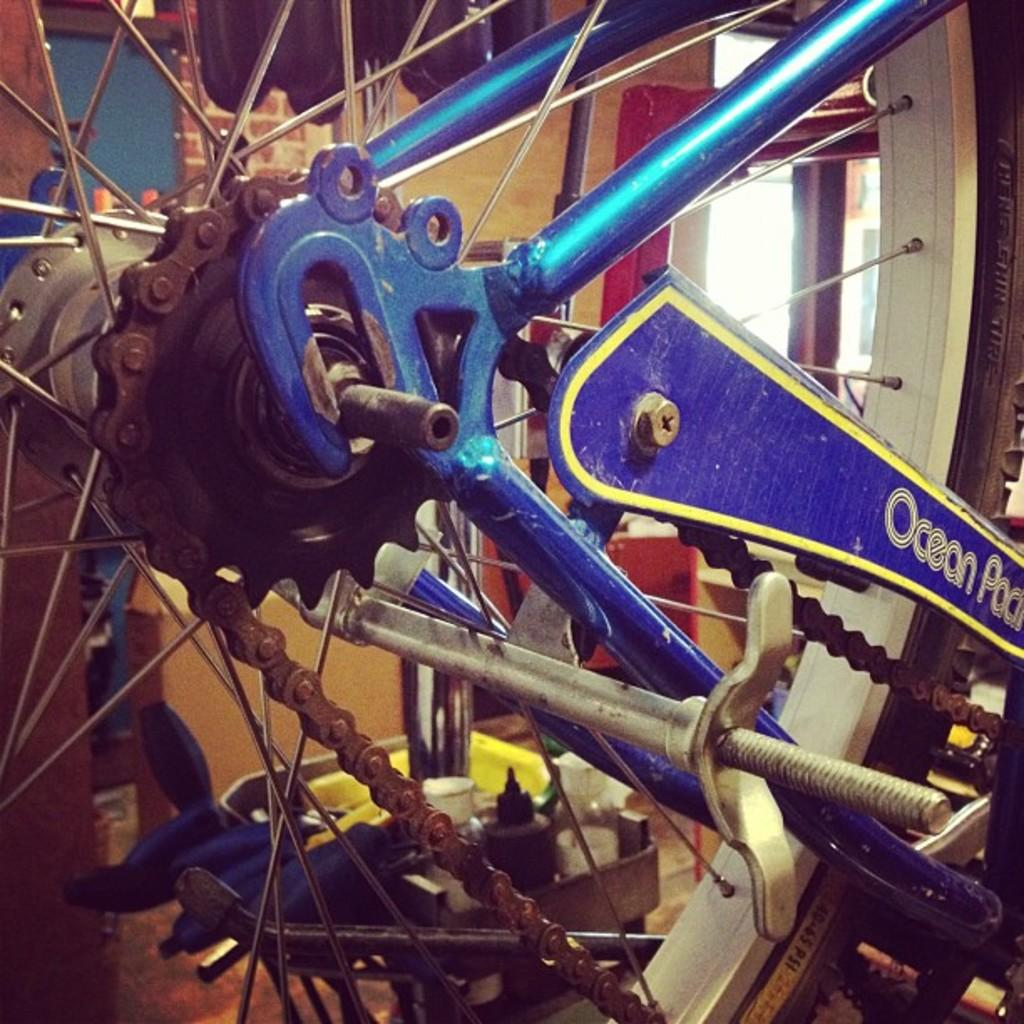What is the main subject of the image? The main subject of the image is a bicycle. What color is the bicycle? The bicycle is blue in color. What color is the wheel of the bicycle? The bicycle's wheel is white in color. What can be seen in the background of the image? There is a wall and objects on the floor in the background of the image. What type of reward is hanging from the handlebars of the bicycle in the image? There is no reward hanging from the handlebars of the bicycle in the image. Can you tell me how many cubs are playing on the street in the image? There are no cubs or streets present in the image; it features a blue bicycle with a white wheel and a background with a wall and objects on the floor. 